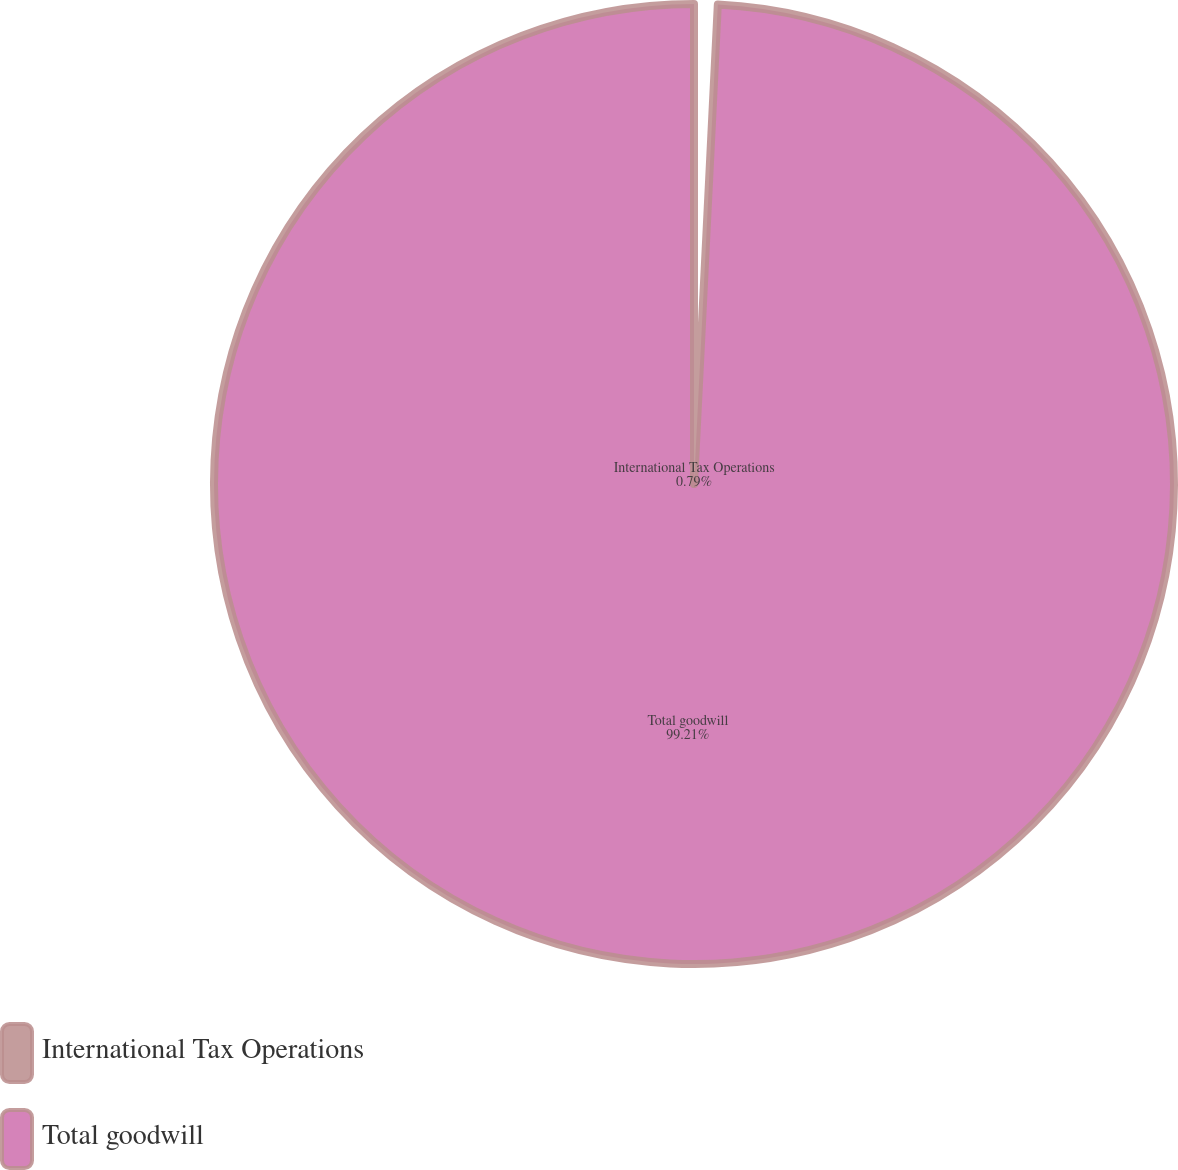<chart> <loc_0><loc_0><loc_500><loc_500><pie_chart><fcel>International Tax Operations<fcel>Total goodwill<nl><fcel>0.79%<fcel>99.21%<nl></chart> 